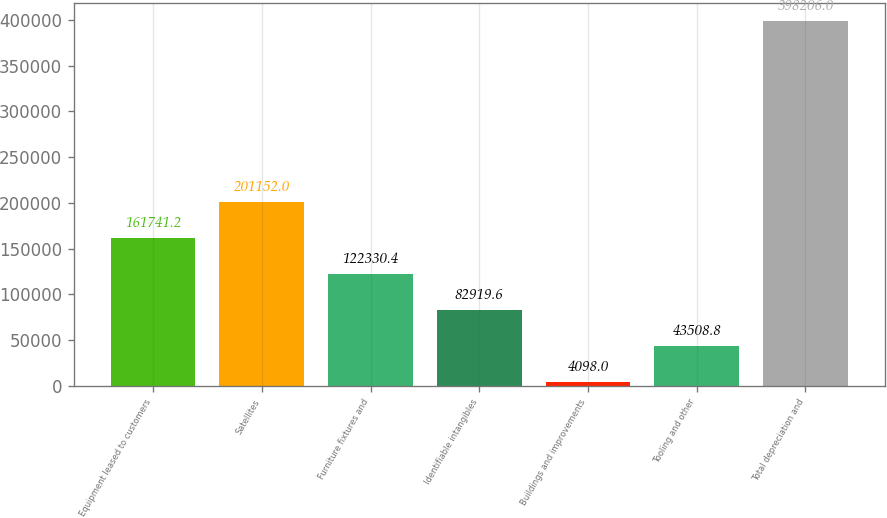Convert chart. <chart><loc_0><loc_0><loc_500><loc_500><bar_chart><fcel>Equipment leased to customers<fcel>Satellites<fcel>Furniture fixtures and<fcel>Identifiable intangibles<fcel>Buildings and improvements<fcel>Tooling and other<fcel>Total depreciation and<nl><fcel>161741<fcel>201152<fcel>122330<fcel>82919.6<fcel>4098<fcel>43508.8<fcel>398206<nl></chart> 